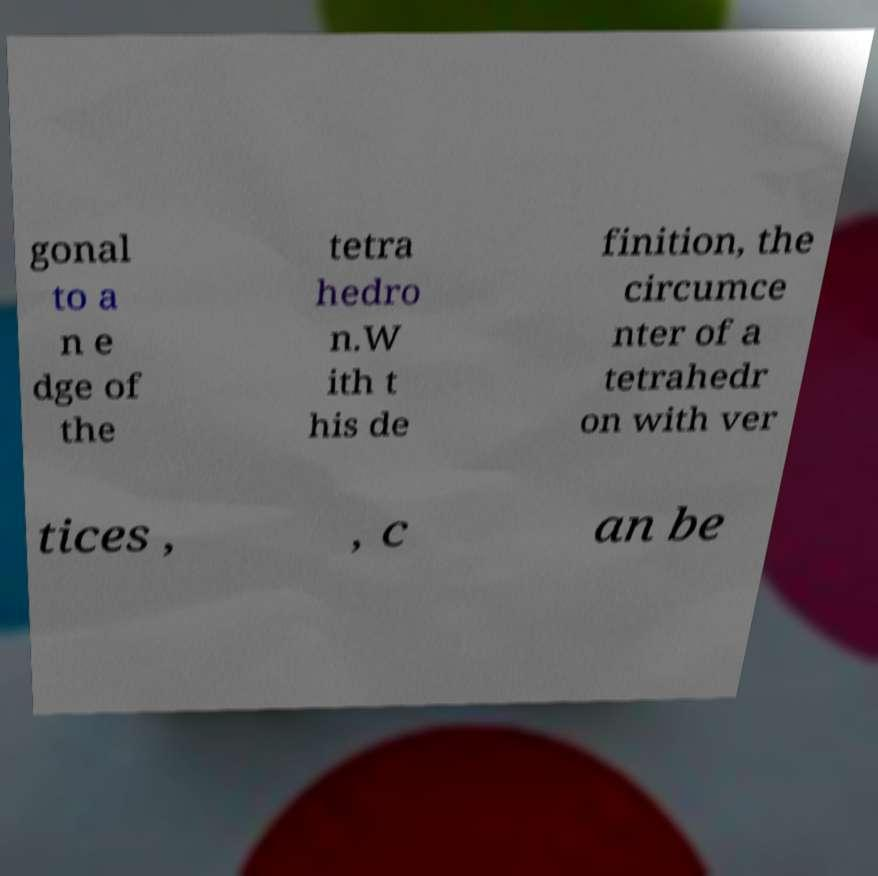Could you extract and type out the text from this image? gonal to a n e dge of the tetra hedro n.W ith t his de finition, the circumce nter of a tetrahedr on with ver tices , , c an be 